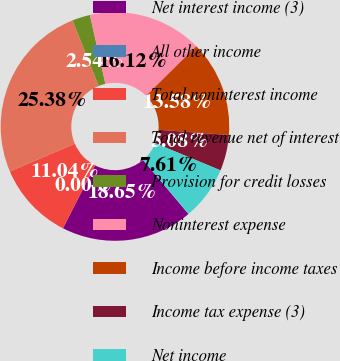Convert chart to OTSL. <chart><loc_0><loc_0><loc_500><loc_500><pie_chart><fcel>Net interest income (3)<fcel>All other income<fcel>Total noninterest income<fcel>Total revenue net of interest<fcel>Provision for credit losses<fcel>Noninterest expense<fcel>Income before income taxes<fcel>Income tax expense (3)<fcel>Net income<nl><fcel>18.65%<fcel>0.0%<fcel>11.04%<fcel>25.38%<fcel>2.54%<fcel>16.12%<fcel>13.58%<fcel>5.08%<fcel>7.61%<nl></chart> 